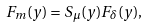Convert formula to latex. <formula><loc_0><loc_0><loc_500><loc_500>F _ { m } ( y ) = S _ { \mu } ( y ) F _ { \delta } ( y ) ,</formula> 